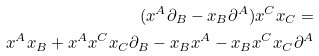<formula> <loc_0><loc_0><loc_500><loc_500>( x ^ { A } \partial _ { B } - x _ { B } \partial ^ { A } ) x ^ { C } x _ { C } = \\ x ^ { A } x _ { B } + x ^ { A } x ^ { C } x _ { C } \partial _ { B } - x _ { B } x ^ { A } - x _ { B } x ^ { C } x _ { C } \partial ^ { A }</formula> 